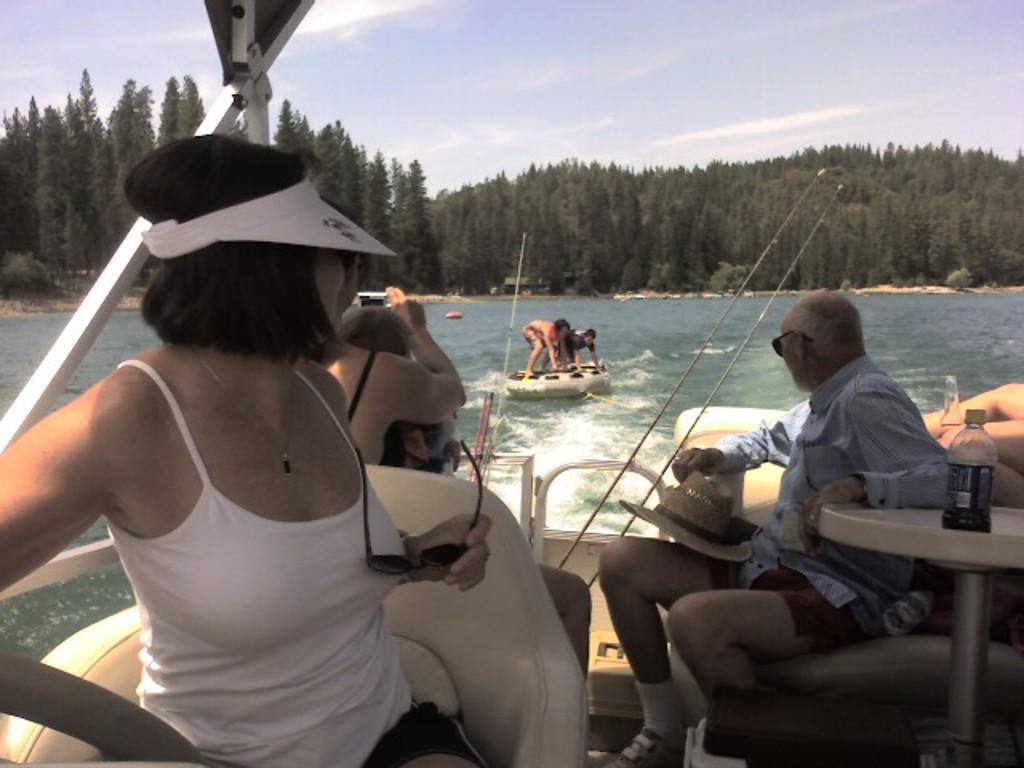Describe this image in one or two sentences. In the picture there is a old woman sitting on the boat seat. Behind there are two old men sitting and watching to the persons who are standing on the boat. In the background there is a sea water and many trees. 